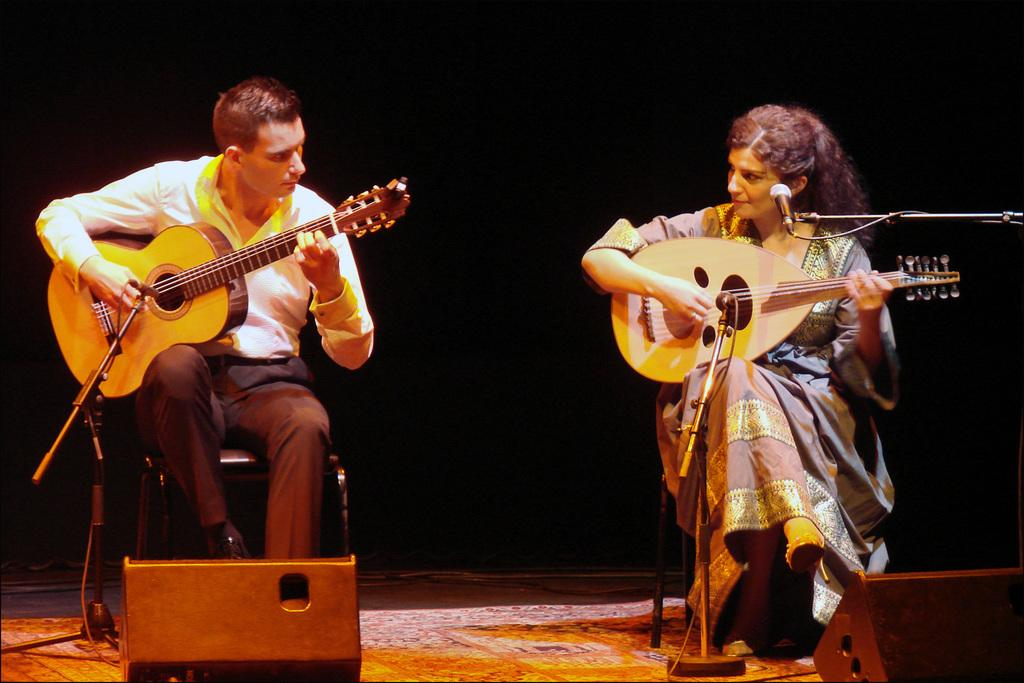What is the man in the image doing? The man is playing a guitar in the image. Who is the man looking at in the image? The man is looking at a woman in the image. What is the woman in the image doing? The woman is playing a musical instrument in the image. What is in front of the woman in the image? There is a microphone in front of the woman in the image. How would you describe the lighting in the image? The background of the image is dark. What type of motion can be seen in the image? There is no motion visible in the image; both the man and the woman are stationary while playing their respective musical instruments. What type of show is being performed in the image? There is no indication of a show being performed in the image; it simply shows a man playing a guitar and a woman playing a musical instrument with a microphone in front of her. 